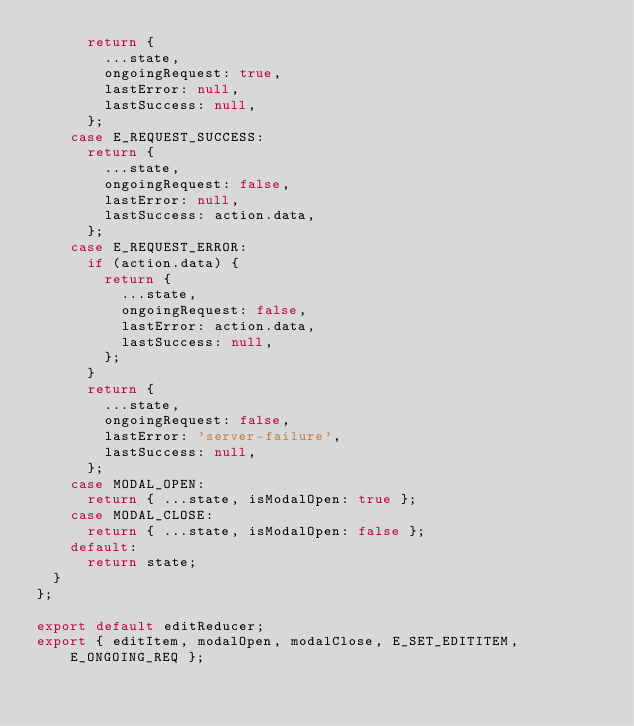Convert code to text. <code><loc_0><loc_0><loc_500><loc_500><_JavaScript_>      return {
        ...state,
        ongoingRequest: true,
        lastError: null,
        lastSuccess: null,
      };
    case E_REQUEST_SUCCESS:
      return {
        ...state,
        ongoingRequest: false,
        lastError: null,
        lastSuccess: action.data,
      };
    case E_REQUEST_ERROR:
      if (action.data) {
        return {
          ...state,
          ongoingRequest: false,
          lastError: action.data,
          lastSuccess: null,
        };
      }
      return {
        ...state,
        ongoingRequest: false,
        lastError: 'server-failure',
        lastSuccess: null,
      };
    case MODAL_OPEN:
      return { ...state, isModalOpen: true };
    case MODAL_CLOSE:
      return { ...state, isModalOpen: false };
    default:
      return state;
  }
};

export default editReducer;
export { editItem, modalOpen, modalClose, E_SET_EDITITEM, E_ONGOING_REQ };
</code> 